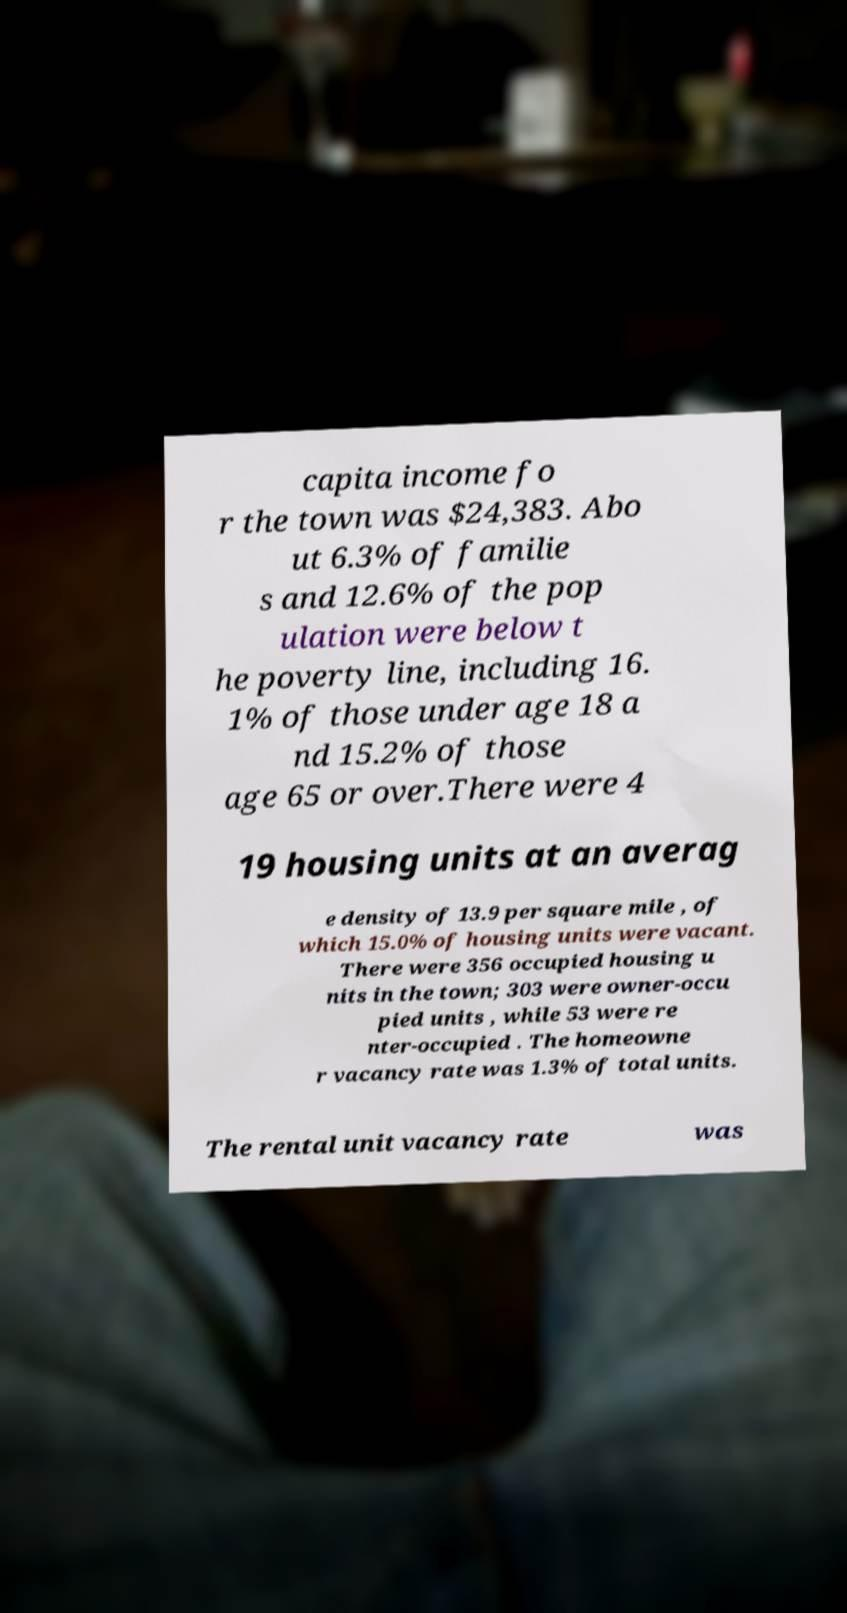Could you extract and type out the text from this image? capita income fo r the town was $24,383. Abo ut 6.3% of familie s and 12.6% of the pop ulation were below t he poverty line, including 16. 1% of those under age 18 a nd 15.2% of those age 65 or over.There were 4 19 housing units at an averag e density of 13.9 per square mile , of which 15.0% of housing units were vacant. There were 356 occupied housing u nits in the town; 303 were owner-occu pied units , while 53 were re nter-occupied . The homeowne r vacancy rate was 1.3% of total units. The rental unit vacancy rate was 